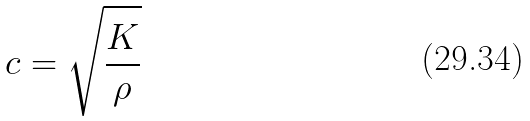Convert formula to latex. <formula><loc_0><loc_0><loc_500><loc_500>c = \sqrt { \frac { K } { \rho } }</formula> 